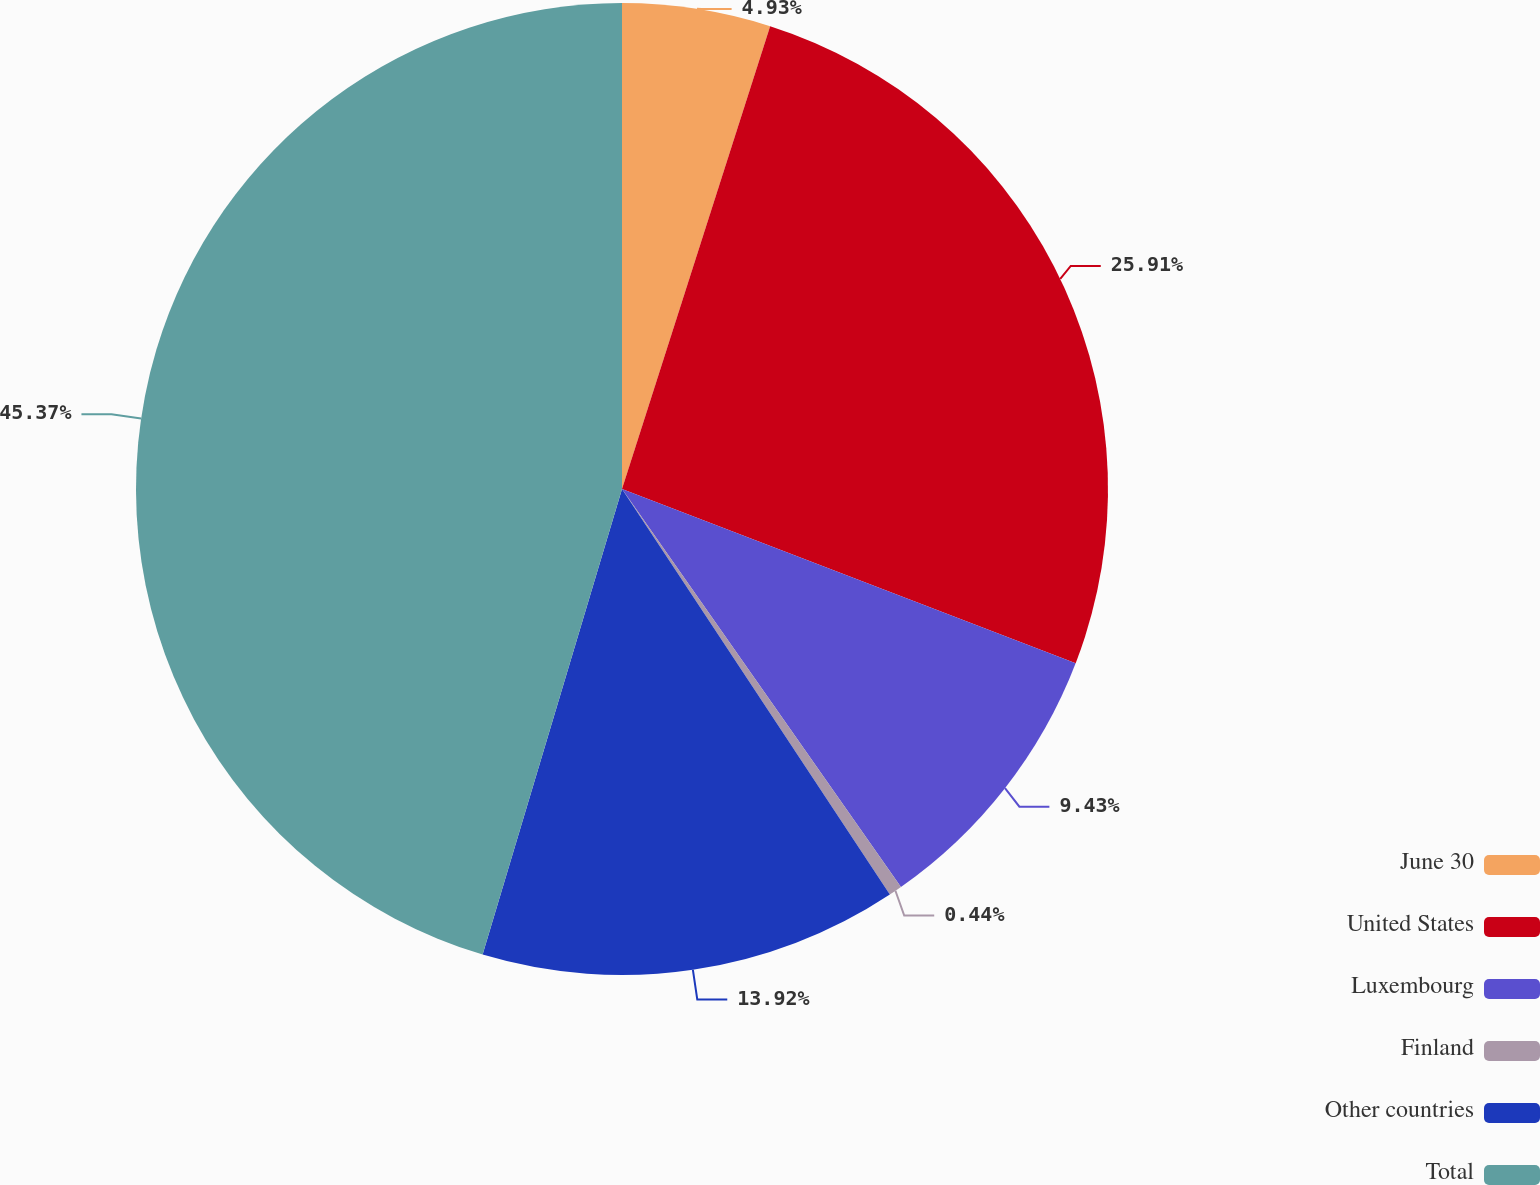<chart> <loc_0><loc_0><loc_500><loc_500><pie_chart><fcel>June 30<fcel>United States<fcel>Luxembourg<fcel>Finland<fcel>Other countries<fcel>Total<nl><fcel>4.93%<fcel>25.91%<fcel>9.43%<fcel>0.44%<fcel>13.92%<fcel>45.37%<nl></chart> 